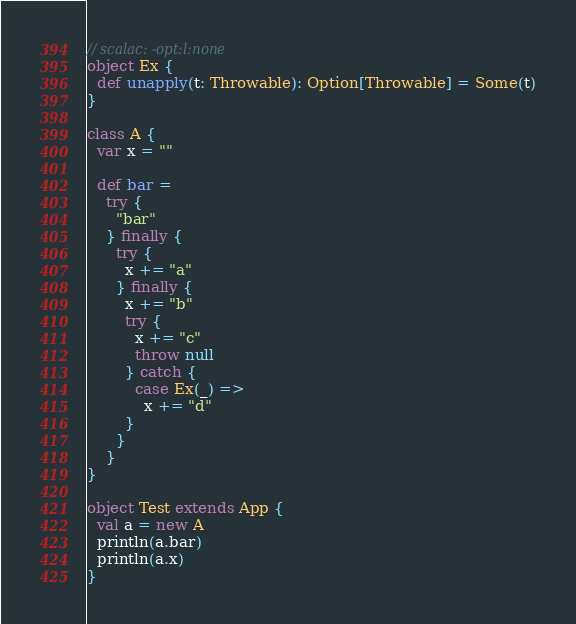<code> <loc_0><loc_0><loc_500><loc_500><_Scala_>// scalac: -opt:l:none
object Ex {
  def unapply(t: Throwable): Option[Throwable] = Some(t)
}

class A {
  var x = ""

  def bar =
    try {
      "bar"
    } finally {
      try {
        x += "a"
      } finally {
        x += "b"
        try {
          x += "c"
          throw null
        } catch {
          case Ex(_) =>
            x += "d"
        }
      }
    }
}

object Test extends App {
  val a = new A
  println(a.bar)
  println(a.x)
}
</code> 